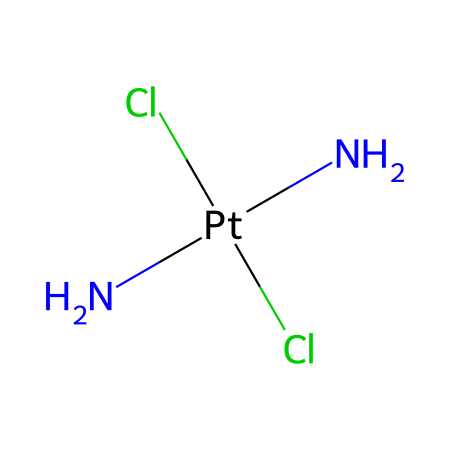How many nitrogen atoms are in cisplatin? The SMILES representation shows "N[Pt](N)(Cl)Cl," which indicates there are two nitrogen (N) atoms connected to the platinum (Pt) atom. By counting the "N" symbols in the SMILES, the answer is confirmed.
Answer: 2 What is the coordination number of the platinum atom in cisplatin? In the chemical structure, the platinum atom is surrounded by four substituents: two nitrogen atoms and two chloride ions. The coordination number refers to the number of atoms directly bonded to a central atom, which in this case is four.
Answer: 4 What type of bonding is present between platinum and nitrogen in cisplatin? The SMILES notation shows the nitrogen atoms are directly bonded to the platinum atom, representing coordinate covalent bonding typical in organometallic compounds, where metal centers coordinate with electron-pair donors.
Answer: coordinate covalent What are the ligands present in cisplatin? The ligands are defined as atoms or molecules that can bond to the central metal atom. Examining the SMILES, the ligands connected to platinum (Pt) are two nitrogen (N) atoms and two chloride (Cl) atoms.
Answer: nitrogen and chloride What is the oxidation state of platinum in cisplatin? In the structure, each nitrogen atom contributes a -2 charge when bonded to the platinum. The two chloride atoms contribute -1 each. Since the overall charge of the compound is neutral, the oxidation state of platinum can be calculated as +2 to balance the -4 charge from the ligands.
Answer: +2 Which type of organometallic compound is cisplatin? Cisplatin is classified as a coordination compound within the organometallic realm because it contains a transition metal (platinum) bonded to organic ligands (nitrogen and chloride) in a definite geometry.
Answer: coordination compound What geometric configuration is expected for cisplatin? Given the presence of two sets of ligands (two nitrogen and two chloride), cisplatin adopts a square planar geometry around the platinum center, which is common for d8 metal complexes like platinum(II).
Answer: square planar 